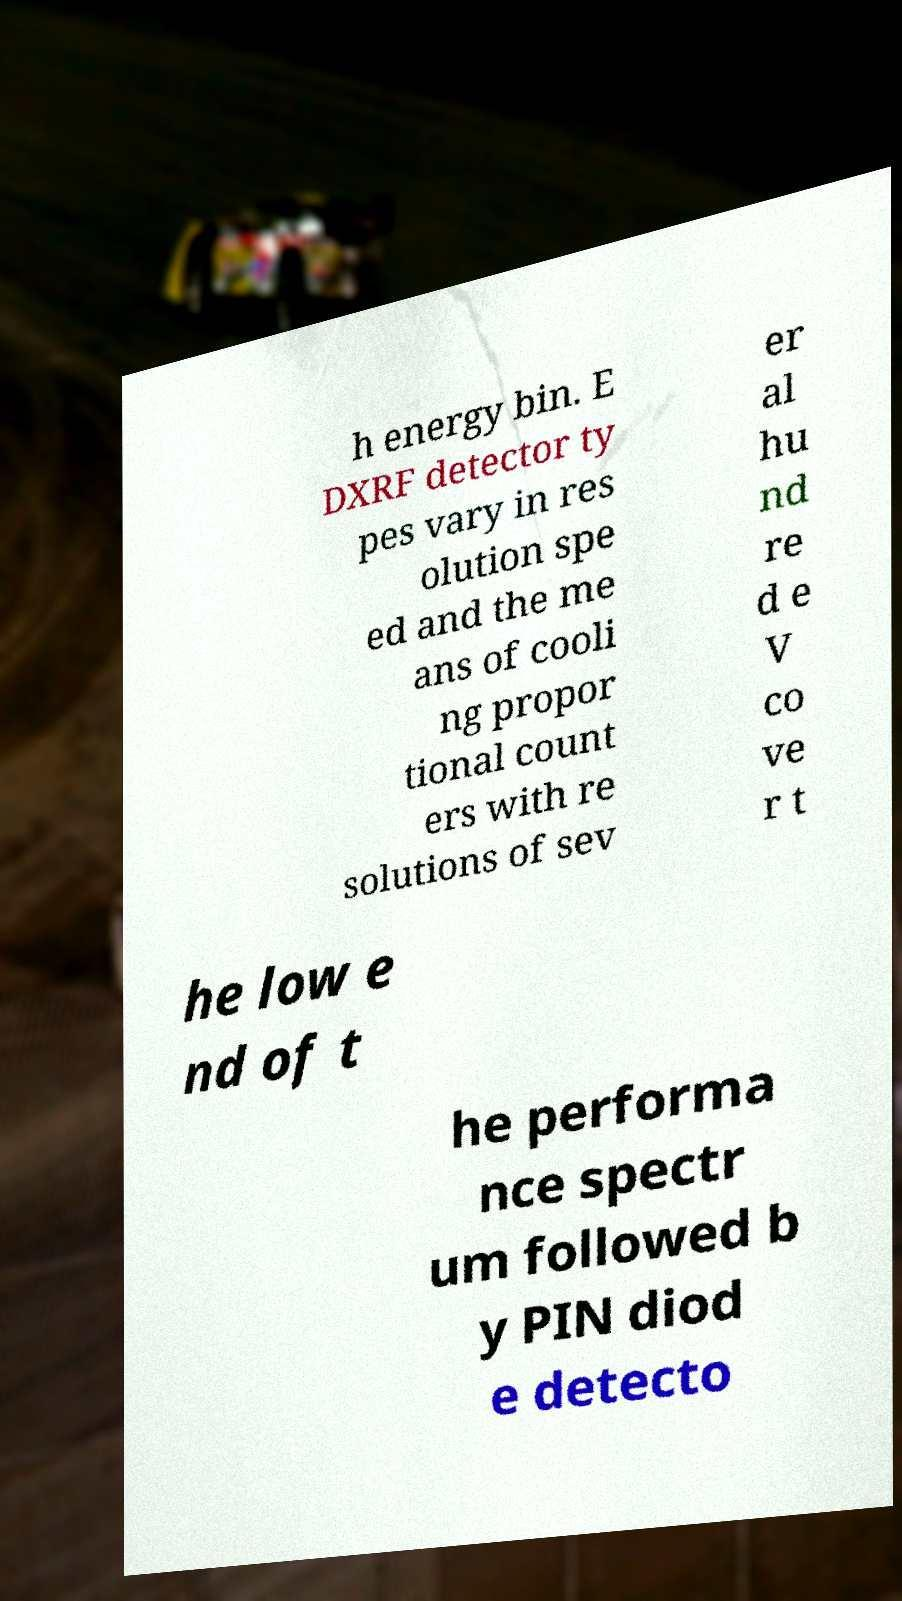For documentation purposes, I need the text within this image transcribed. Could you provide that? h energy bin. E DXRF detector ty pes vary in res olution spe ed and the me ans of cooli ng propor tional count ers with re solutions of sev er al hu nd re d e V co ve r t he low e nd of t he performa nce spectr um followed b y PIN diod e detecto 